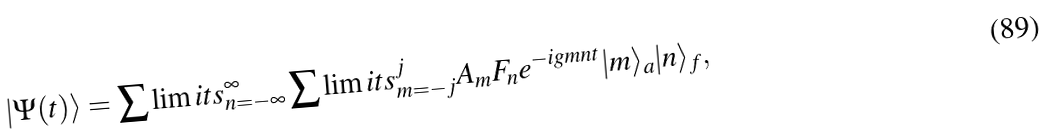Convert formula to latex. <formula><loc_0><loc_0><loc_500><loc_500>\left | { \Psi ( t ) } \right \rangle = \sum \lim i t s _ { n = - \infty } ^ { \infty } \sum \lim i t s _ { m = - j } ^ { j } { A _ { m } } F _ { n } e ^ { - i g m n t } | m \rangle _ { a } | { n } \rangle _ { f } ,</formula> 